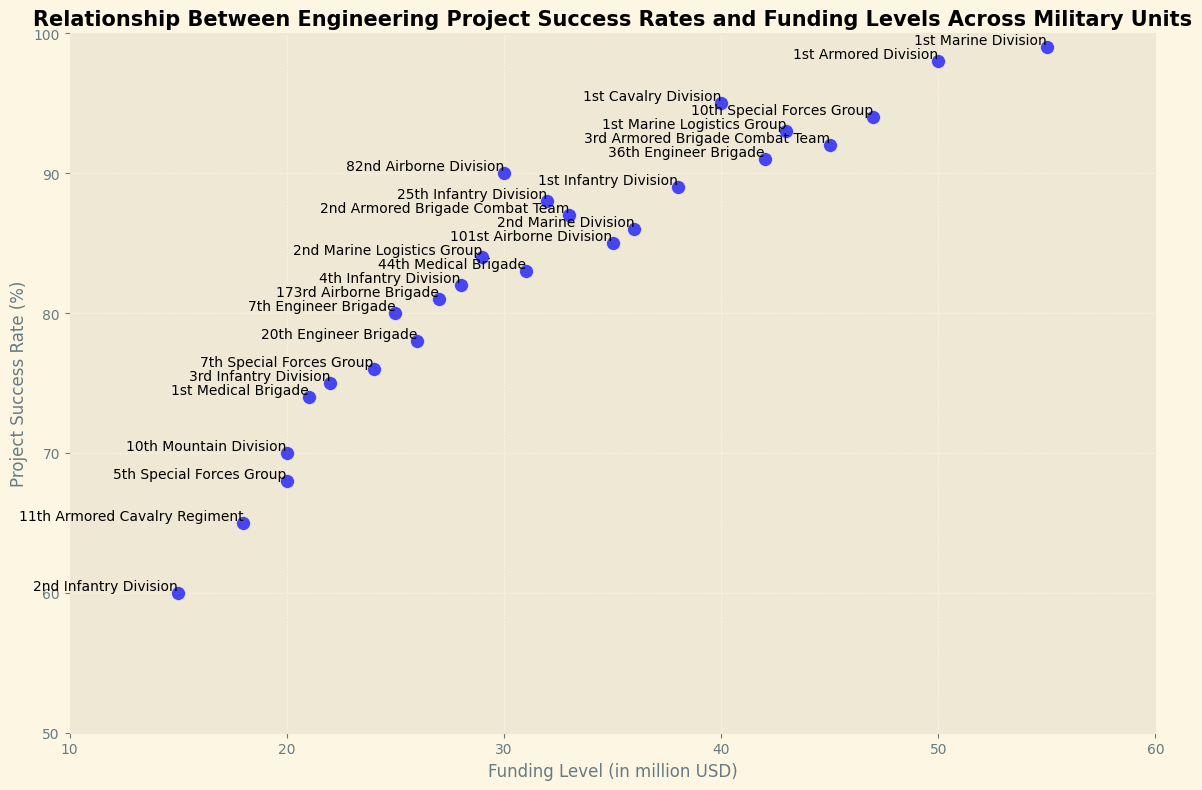What's the unit with the highest project success rate? Examine the vertical axis (Project Success Rate %) and look for the highest plotted point. The unit name is annotated next to the point.
Answer: 1st Marine Division Which unit has the lowest funding level, and what is their project success rate? Check the horizontal axis (Funding Level in million USD) and identify the point furthest to the left. The unit name and project success rate are annotated next to this point.
Answer: 2nd Infantry Division, 60% What is the difference in project success rates between the 10th Special Forces Group and the 2nd Infantry Division? Find the points for both units. The 10th Special Forces Group has a success rate of 94%, and the 2nd Infantry Division has 60%. Calculate the difference: 94% - 60% = 34%.
Answer: 34% Which unit has a higher project success rate: 82nd Airborne Division or 1st Infantry Division? Examine the points for both units. The 82nd Airborne Division has a project success rate of 90%, and the 1st Infantry Division has 89%. Compare the two values.
Answer: 82nd Airborne Division What is the average funding level of the 7th Engineer Brigade and the 20th Engineer Brigade? The 7th Engineer Brigade has a funding level of 25 million USD, and the 20th Engineer Brigade has 26 million USD. Calculate the average: (25 + 26) / 2 = 25.5 million USD.
Answer: 25.5 million USD Which unit with a funding level higher than 40 million USD has the lowest project success rate? Identify all units with funding levels above 40 million USD and compare their project success rates. The 36th Engineer Brigade has a success rate of 91%, which is the lowest among units with funding exceeding 40 million USD.
Answer: 36th Engineer Brigade What funding level corresponds to the lowest project success rate, and which unit does it belong to? Find the point with the lowest value on the vertical axis (Project Success Rate %). The point corresponds to a funding level of 15 million USD and belongs to the 2nd Infantry Division.
Answer: 15 million USD, 2nd Infantry Division What's the average project success rate of units with funding levels between 20 million USD and 30 million USD? Identify units within the funding range: 10th Mountain Division (70%), 5th Special Forces Group (68%), 1st Medical Brigade (74%), 3rd Infantry Division (75%), 44th Medical Brigade (83%), 7th Special Forces Group (76%), 7th Engineer Brigade (80%), and 11th Armored Cavalry Regiment (65%). Calculate the average: (70 + 68 + 74 + 75 + 83 + 76 + 80 + 65) / 8 = 73.875%.
Answer: 73.875% How many units have project success rates above 85%? Count the number of points above the 85% mark on the vertical axis. The units are 1st Marine Division, 1st Armored Division, 1st Cavalry Division, 3rd Armored Brigade Combat Team, 10th Special Forces Group, 1st Marine Logistics Group, 2nd Marine Division, 1st Infantry Division, 25th Infantry Division, 2nd Armored Brigade Combat Team, and 82nd Airborne Division.
Answer: 11 units 